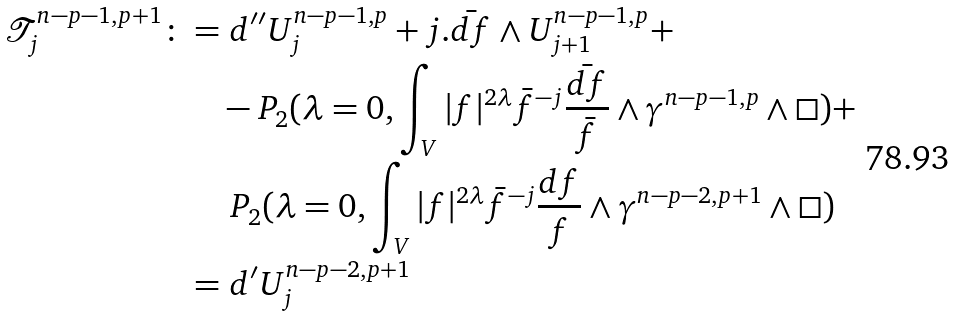<formula> <loc_0><loc_0><loc_500><loc_500>\mathcal { T } ^ { n - p - 1 , p + 1 } _ { j } \colon = & \ d ^ { \prime \prime } U _ { j } ^ { n - p - 1 , p } + j . \bar { d f } \wedge U _ { j + 1 } ^ { n - p - 1 , p } + \\ \quad & - P _ { 2 } ( \lambda = 0 , \int _ { V } | f | ^ { 2 \lambda } \bar { f } ^ { - j } \frac { \bar { d f } } { \bar { f } } \wedge \gamma ^ { n - p - 1 , p } \wedge \Box ) + \\ \quad & \ P _ { 2 } ( \lambda = 0 , \int _ { V } | f | ^ { 2 \lambda } \bar { f } ^ { - j } \frac { d f } { f } \wedge \gamma ^ { n - p - 2 , p + 1 } \wedge \Box ) \\ \quad = & \ d ^ { \prime } U _ { j } ^ { n - p - 2 , p + 1 }</formula> 